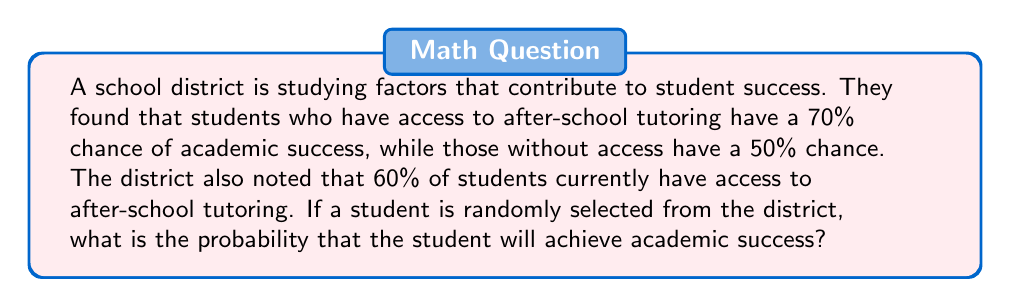Can you answer this question? Let's approach this problem using the law of total probability.

1) Define events:
   A: The student achieves academic success
   T: The student has access to after-school tutoring

2) Given probabilities:
   $P(T) = 0.60$ (60% of students have access to tutoring)
   $P(A|T) = 0.70$ (70% chance of success with tutoring)
   $P(A|\text{not }T) = 0.50$ (50% chance of success without tutoring)

3) Law of Total Probability:
   $$P(A) = P(A|T) \cdot P(T) + P(A|\text{not }T) \cdot P(\text{not }T)$$

4) Calculate $P(\text{not }T)$:
   $P(\text{not }T) = 1 - P(T) = 1 - 0.60 = 0.40$

5) Substitute values into the formula:
   $$P(A) = 0.70 \cdot 0.60 + 0.50 \cdot 0.40$$

6) Calculate:
   $$P(A) = 0.42 + 0.20 = 0.62$$

Therefore, the probability that a randomly selected student will achieve academic success is 0.62 or 62%.
Answer: 0.62 or 62% 